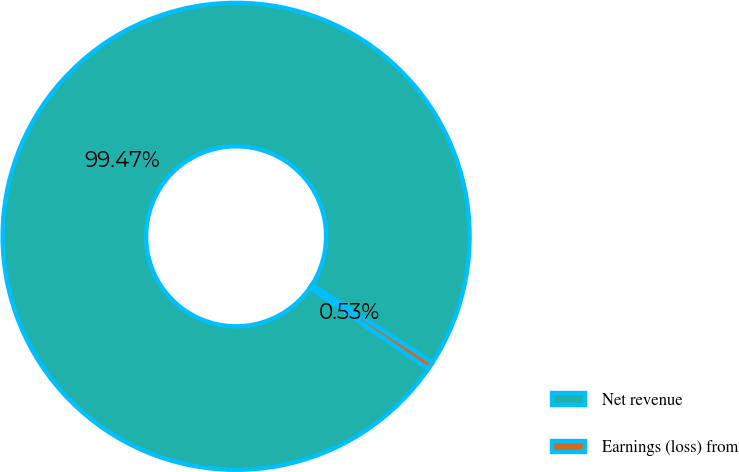<chart> <loc_0><loc_0><loc_500><loc_500><pie_chart><fcel>Net revenue<fcel>Earnings (loss) from<nl><fcel>99.47%<fcel>0.53%<nl></chart> 